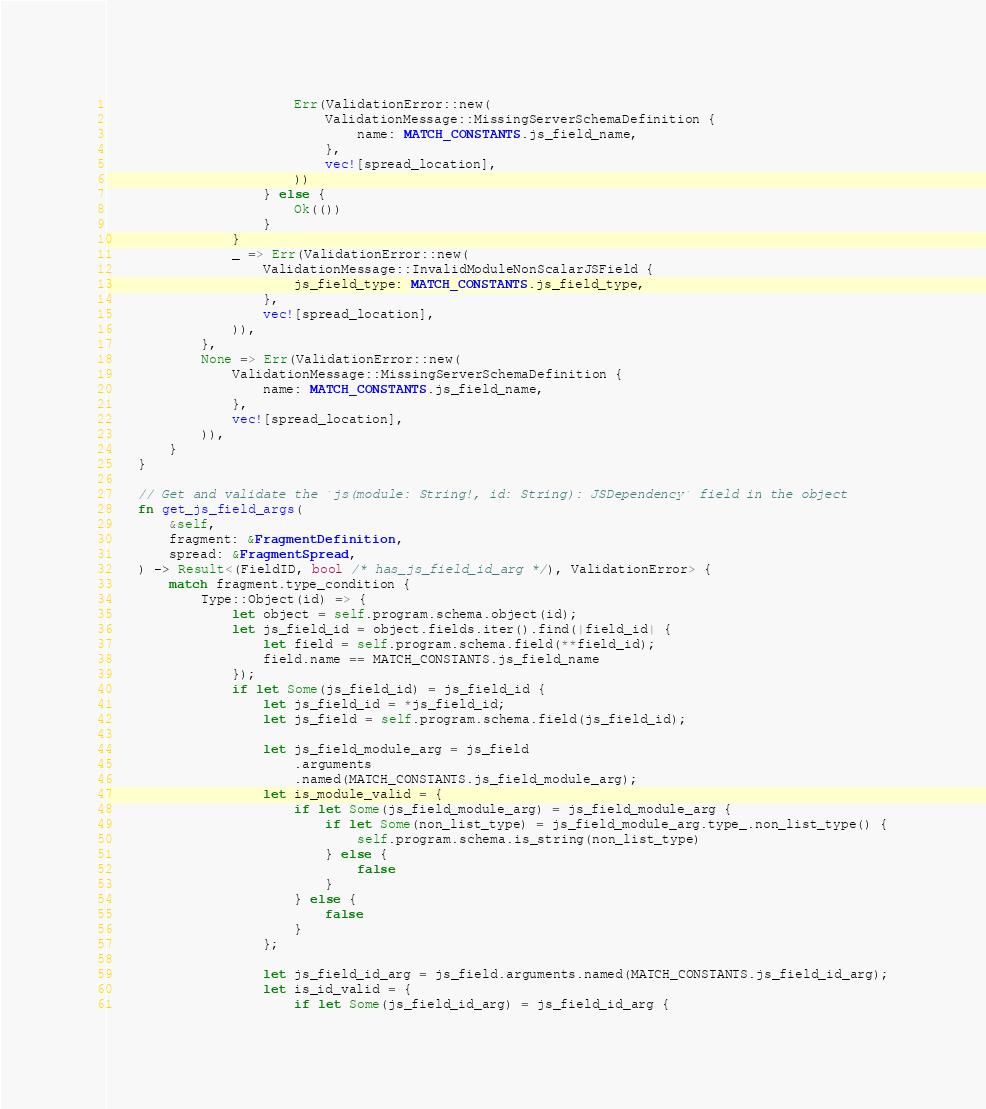Convert code to text. <code><loc_0><loc_0><loc_500><loc_500><_Rust_>                        Err(ValidationError::new(
                            ValidationMessage::MissingServerSchemaDefinition {
                                name: MATCH_CONSTANTS.js_field_name,
                            },
                            vec![spread_location],
                        ))
                    } else {
                        Ok(())
                    }
                }
                _ => Err(ValidationError::new(
                    ValidationMessage::InvalidModuleNonScalarJSField {
                        js_field_type: MATCH_CONSTANTS.js_field_type,
                    },
                    vec![spread_location],
                )),
            },
            None => Err(ValidationError::new(
                ValidationMessage::MissingServerSchemaDefinition {
                    name: MATCH_CONSTANTS.js_field_name,
                },
                vec![spread_location],
            )),
        }
    }

    // Get and validate the `js(module: String!, id: String): JSDependency` field in the object
    fn get_js_field_args(
        &self,
        fragment: &FragmentDefinition,
        spread: &FragmentSpread,
    ) -> Result<(FieldID, bool /* has_js_field_id_arg */), ValidationError> {
        match fragment.type_condition {
            Type::Object(id) => {
                let object = self.program.schema.object(id);
                let js_field_id = object.fields.iter().find(|field_id| {
                    let field = self.program.schema.field(**field_id);
                    field.name == MATCH_CONSTANTS.js_field_name
                });
                if let Some(js_field_id) = js_field_id {
                    let js_field_id = *js_field_id;
                    let js_field = self.program.schema.field(js_field_id);

                    let js_field_module_arg = js_field
                        .arguments
                        .named(MATCH_CONSTANTS.js_field_module_arg);
                    let is_module_valid = {
                        if let Some(js_field_module_arg) = js_field_module_arg {
                            if let Some(non_list_type) = js_field_module_arg.type_.non_list_type() {
                                self.program.schema.is_string(non_list_type)
                            } else {
                                false
                            }
                        } else {
                            false
                        }
                    };

                    let js_field_id_arg = js_field.arguments.named(MATCH_CONSTANTS.js_field_id_arg);
                    let is_id_valid = {
                        if let Some(js_field_id_arg) = js_field_id_arg {</code> 